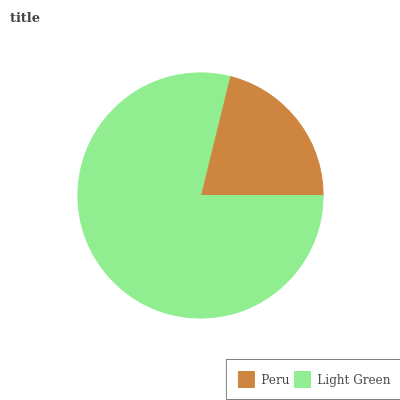Is Peru the minimum?
Answer yes or no. Yes. Is Light Green the maximum?
Answer yes or no. Yes. Is Light Green the minimum?
Answer yes or no. No. Is Light Green greater than Peru?
Answer yes or no. Yes. Is Peru less than Light Green?
Answer yes or no. Yes. Is Peru greater than Light Green?
Answer yes or no. No. Is Light Green less than Peru?
Answer yes or no. No. Is Light Green the high median?
Answer yes or no. Yes. Is Peru the low median?
Answer yes or no. Yes. Is Peru the high median?
Answer yes or no. No. Is Light Green the low median?
Answer yes or no. No. 